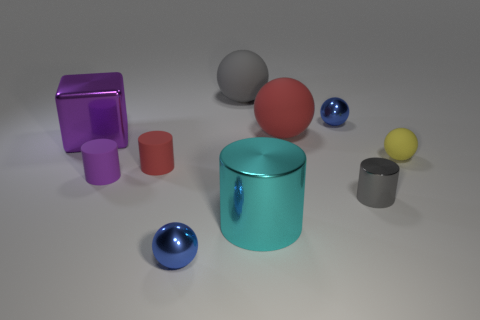Subtract 2 balls. How many balls are left? 3 Subtract all red spheres. How many spheres are left? 4 Subtract all gray spheres. How many spheres are left? 4 Subtract all purple spheres. Subtract all cyan cylinders. How many spheres are left? 5 Subtract all cylinders. How many objects are left? 6 Add 7 small red cylinders. How many small red cylinders exist? 8 Subtract 1 purple cylinders. How many objects are left? 9 Subtract all red rubber cylinders. Subtract all small purple cylinders. How many objects are left? 8 Add 1 big cyan objects. How many big cyan objects are left? 2 